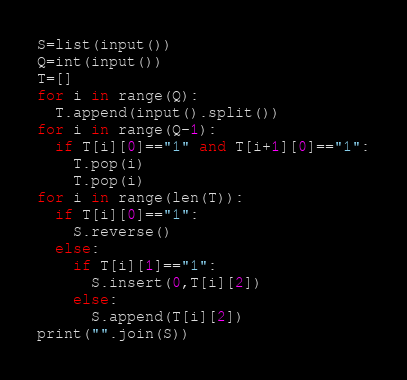Convert code to text. <code><loc_0><loc_0><loc_500><loc_500><_Python_>S=list(input())
Q=int(input())
T=[]
for i in range(Q):
  T.append(input().split())
for i in range(Q-1):
  if T[i][0]=="1" and T[i+1][0]=="1":
    T.pop(i)
    T.pop(i)
for i in range(len(T)):
  if T[i][0]=="1":
    S.reverse()
  else:
    if T[i][1]=="1":
      S.insert(0,T[i][2])
    else:
      S.append(T[i][2])
print("".join(S))</code> 